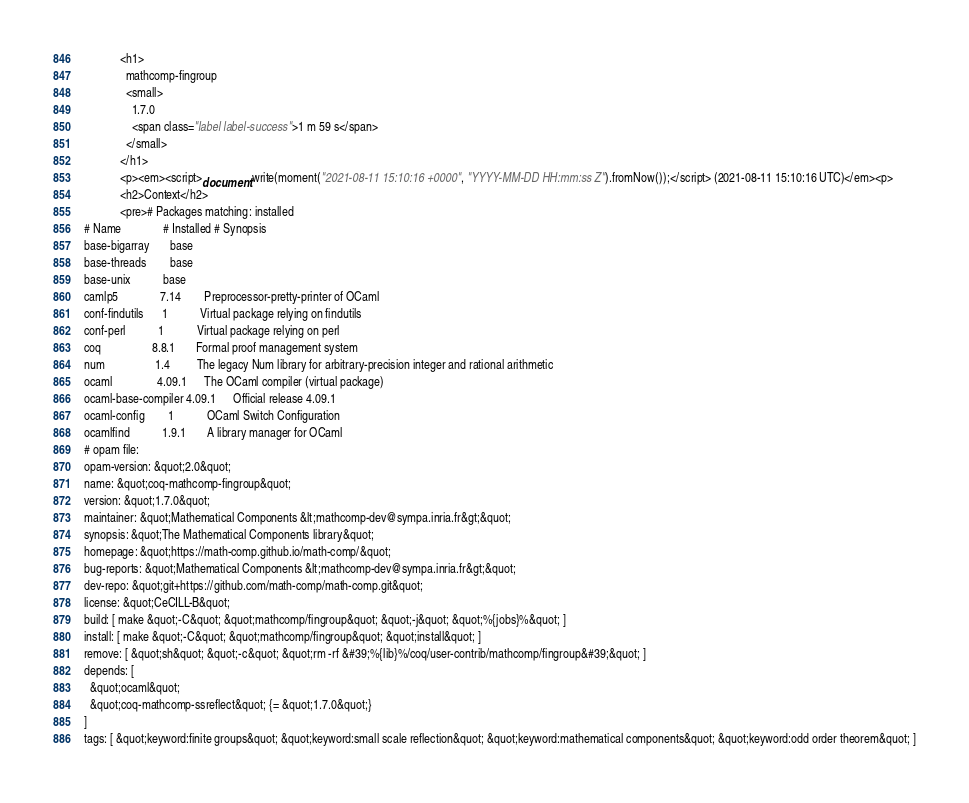<code> <loc_0><loc_0><loc_500><loc_500><_HTML_>            <h1>
              mathcomp-fingroup
              <small>
                1.7.0
                <span class="label label-success">1 m 59 s</span>
              </small>
            </h1>
            <p><em><script>document.write(moment("2021-08-11 15:10:16 +0000", "YYYY-MM-DD HH:mm:ss Z").fromNow());</script> (2021-08-11 15:10:16 UTC)</em><p>
            <h2>Context</h2>
            <pre># Packages matching: installed
# Name              # Installed # Synopsis
base-bigarray       base
base-threads        base
base-unix           base
camlp5              7.14        Preprocessor-pretty-printer of OCaml
conf-findutils      1           Virtual package relying on findutils
conf-perl           1           Virtual package relying on perl
coq                 8.8.1       Formal proof management system
num                 1.4         The legacy Num library for arbitrary-precision integer and rational arithmetic
ocaml               4.09.1      The OCaml compiler (virtual package)
ocaml-base-compiler 4.09.1      Official release 4.09.1
ocaml-config        1           OCaml Switch Configuration
ocamlfind           1.9.1       A library manager for OCaml
# opam file:
opam-version: &quot;2.0&quot;
name: &quot;coq-mathcomp-fingroup&quot;
version: &quot;1.7.0&quot;
maintainer: &quot;Mathematical Components &lt;mathcomp-dev@sympa.inria.fr&gt;&quot;
synopsis: &quot;The Mathematical Components library&quot;
homepage: &quot;https://math-comp.github.io/math-comp/&quot;
bug-reports: &quot;Mathematical Components &lt;mathcomp-dev@sympa.inria.fr&gt;&quot;
dev-repo: &quot;git+https://github.com/math-comp/math-comp.git&quot;
license: &quot;CeCILL-B&quot;
build: [ make &quot;-C&quot; &quot;mathcomp/fingroup&quot; &quot;-j&quot; &quot;%{jobs}%&quot; ]
install: [ make &quot;-C&quot; &quot;mathcomp/fingroup&quot; &quot;install&quot; ]
remove: [ &quot;sh&quot; &quot;-c&quot; &quot;rm -rf &#39;%{lib}%/coq/user-contrib/mathcomp/fingroup&#39;&quot; ]
depends: [
  &quot;ocaml&quot;
  &quot;coq-mathcomp-ssreflect&quot; {= &quot;1.7.0&quot;}
]
tags: [ &quot;keyword:finite groups&quot; &quot;keyword:small scale reflection&quot; &quot;keyword:mathematical components&quot; &quot;keyword:odd order theorem&quot; ]</code> 